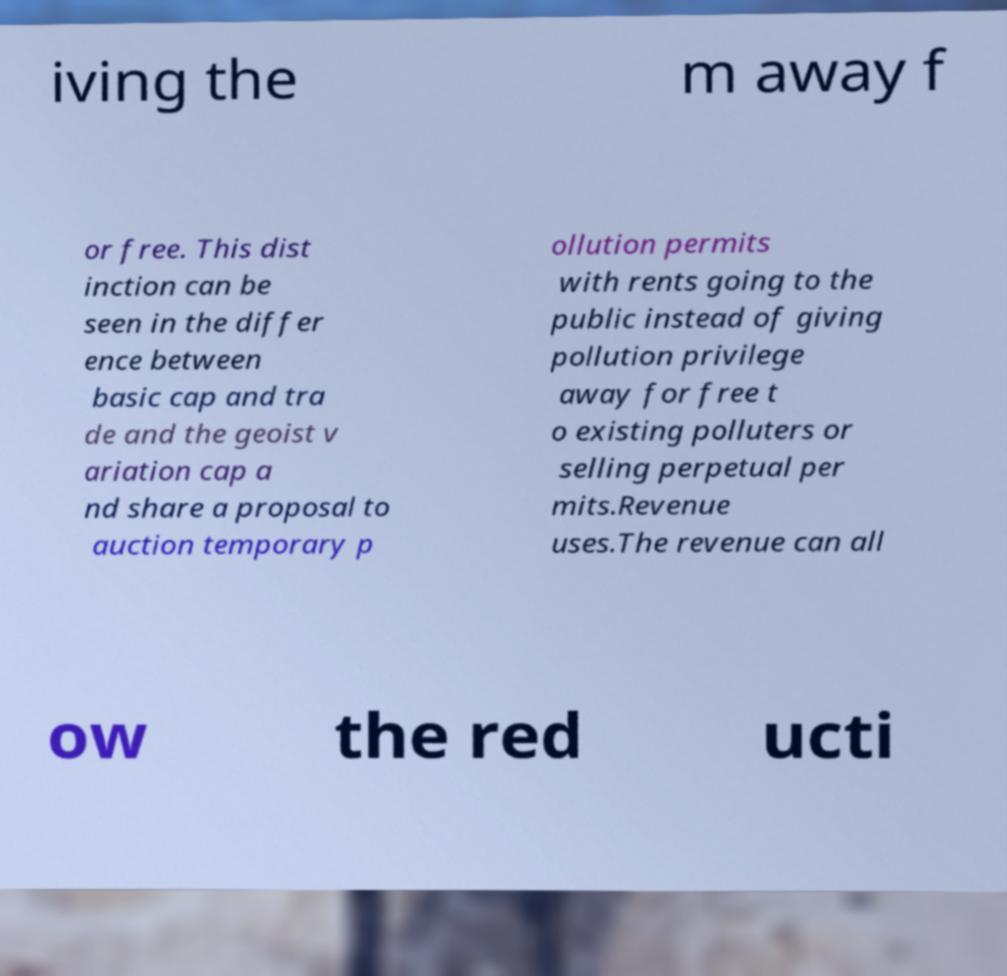Can you accurately transcribe the text from the provided image for me? iving the m away f or free. This dist inction can be seen in the differ ence between basic cap and tra de and the geoist v ariation cap a nd share a proposal to auction temporary p ollution permits with rents going to the public instead of giving pollution privilege away for free t o existing polluters or selling perpetual per mits.Revenue uses.The revenue can all ow the red ucti 